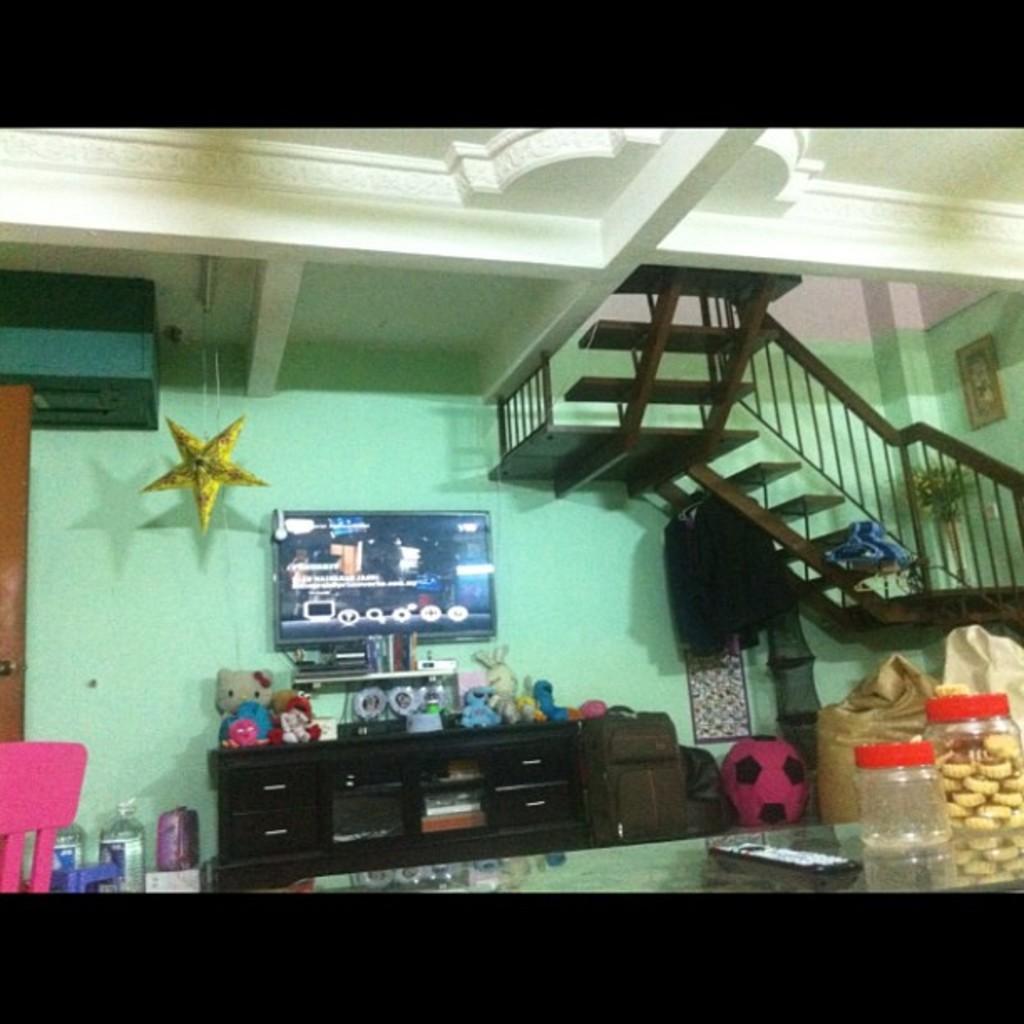In one or two sentences, can you explain what this image depicts? In this picture we can observe a TV. There are some teddy bears and toys placed on the black color desk. We can observe a bag and a ball beside the desk. On the right side there are stairs. In the background we can observe a wall which is in green. There is yellow color star hanging. On the right side there are two jars placed on the table along with a remote. 